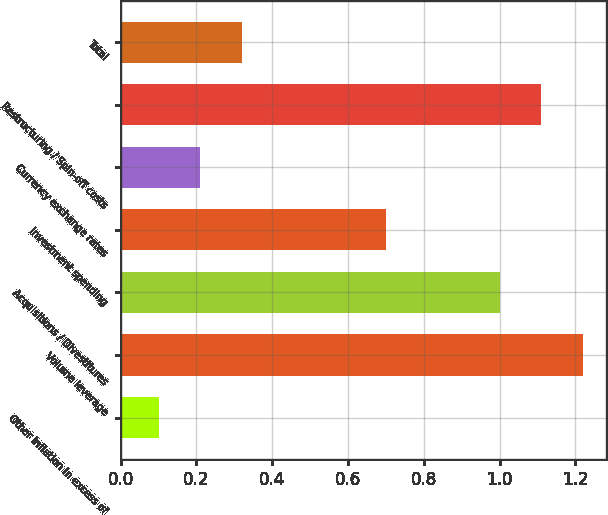<chart> <loc_0><loc_0><loc_500><loc_500><bar_chart><fcel>Other inflation in excess of<fcel>Volume leverage<fcel>Acquisitions / Divestitures<fcel>Investment spending<fcel>Currency exchange rates<fcel>Restructuring / Spin-off costs<fcel>Total<nl><fcel>0.1<fcel>1.22<fcel>1<fcel>0.7<fcel>0.21<fcel>1.11<fcel>0.32<nl></chart> 